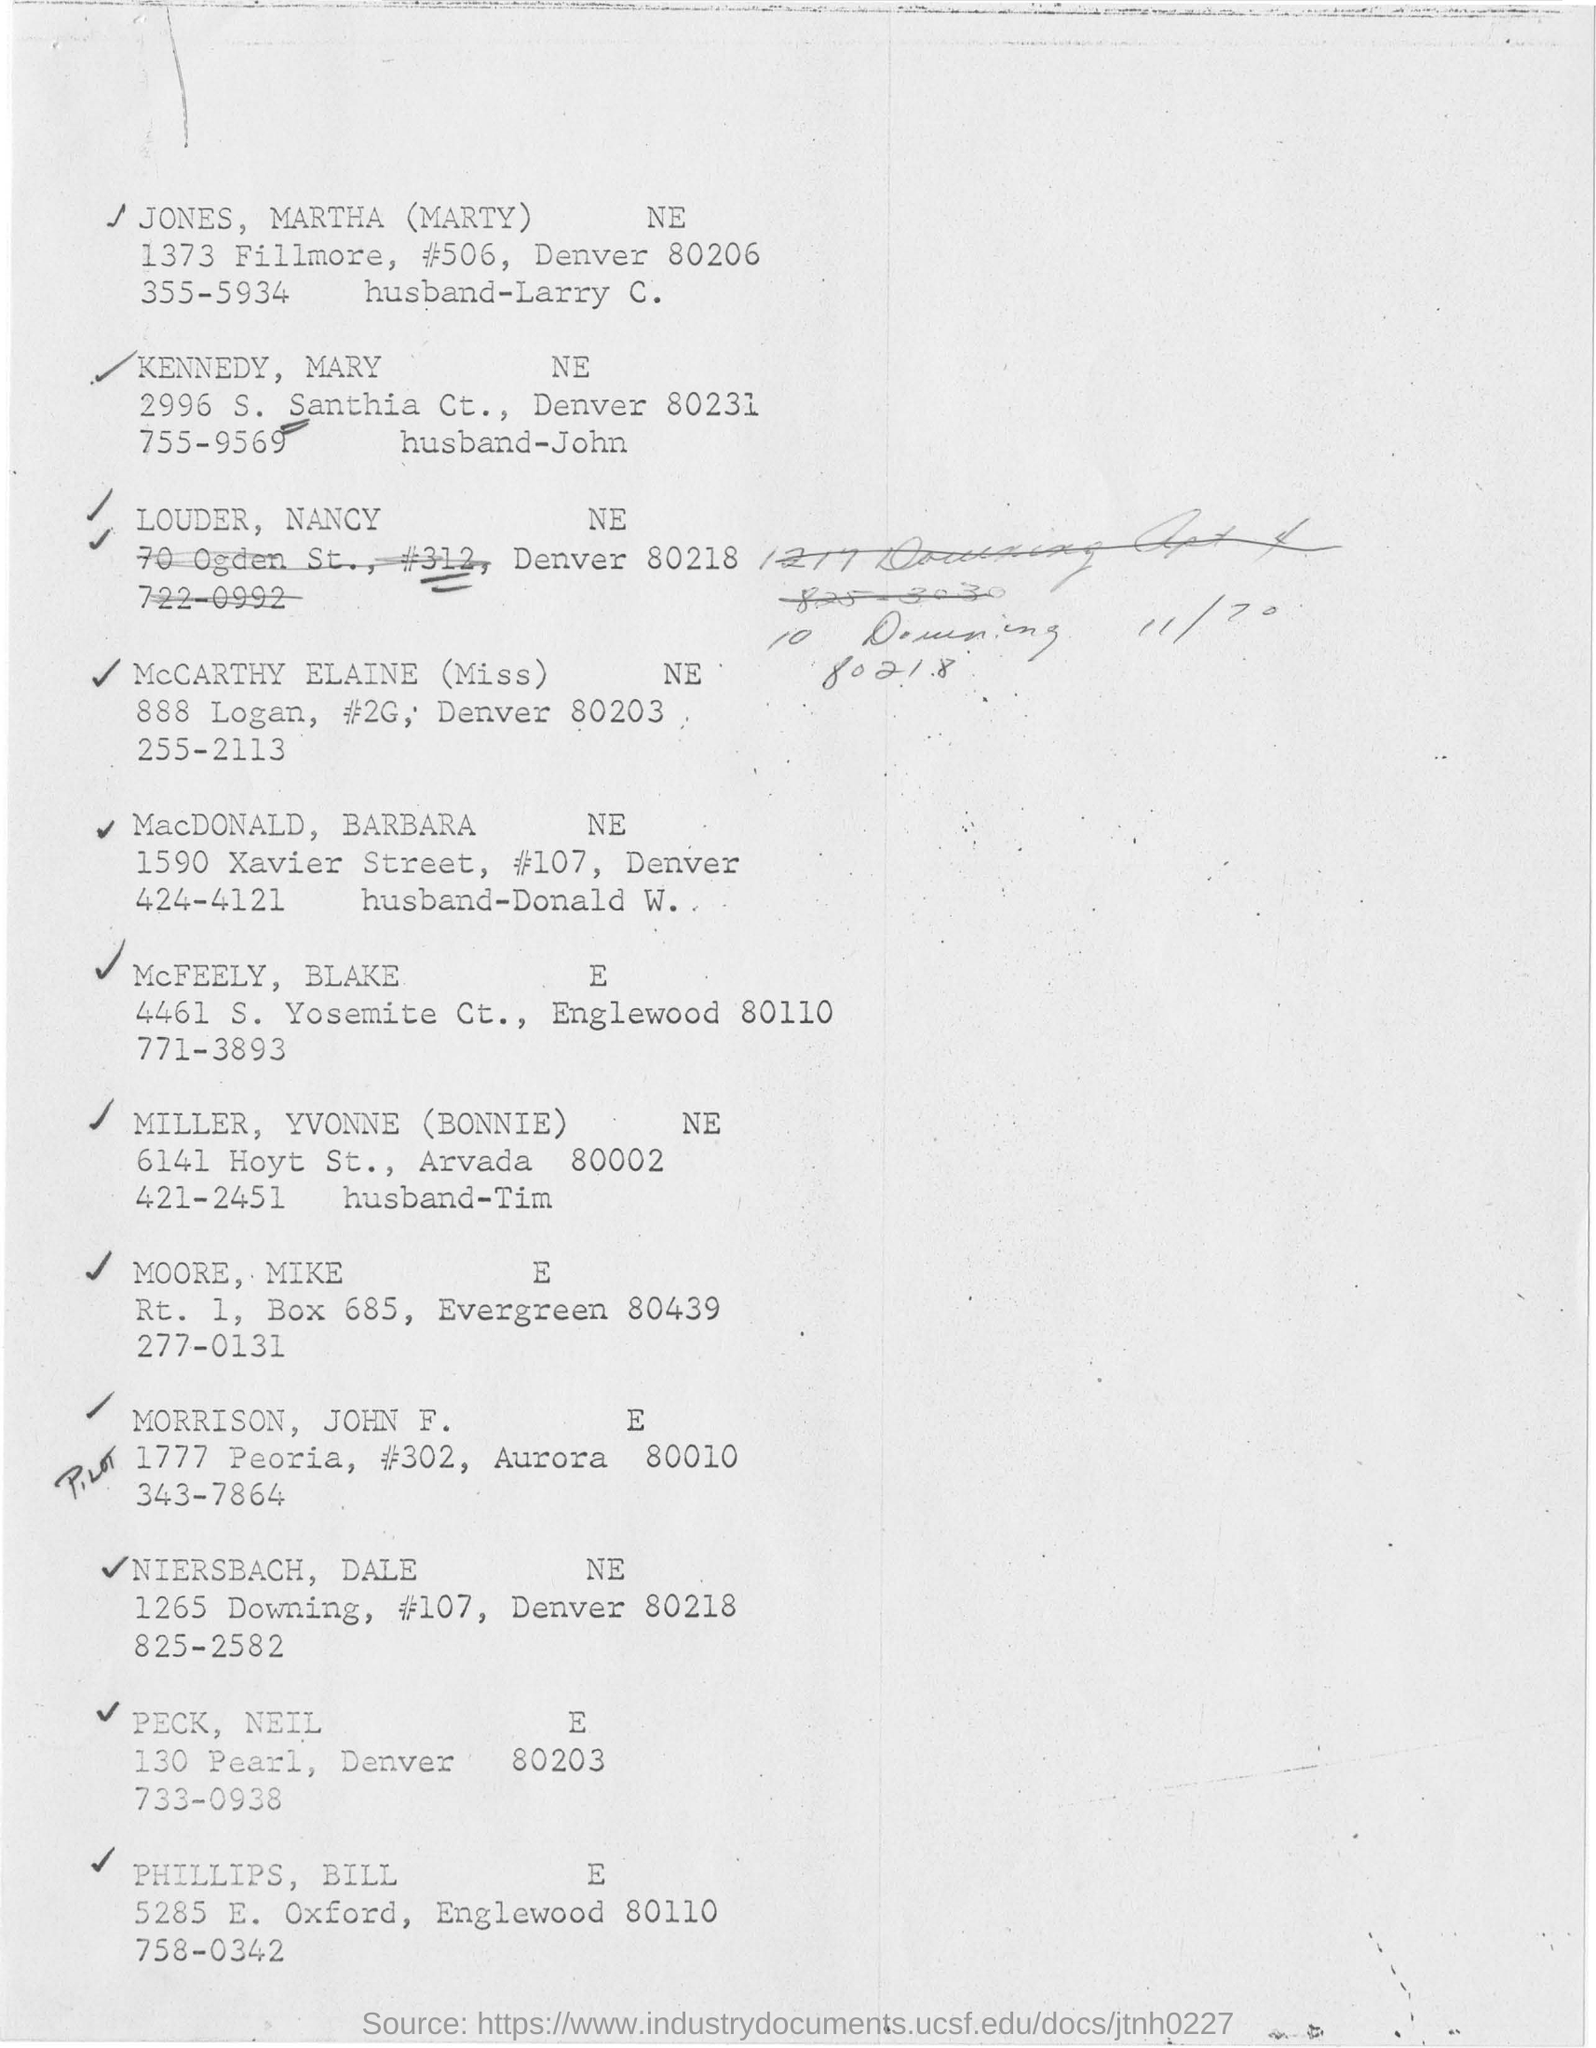What is the name on the first line?
Your answer should be very brief. Jones, Martha. What is the address of mccarthy elaine?
Offer a terse response. 888 LOGAN, #2G, DENVER 80203. Where is santhia ct?
Keep it short and to the point. DENVER. 